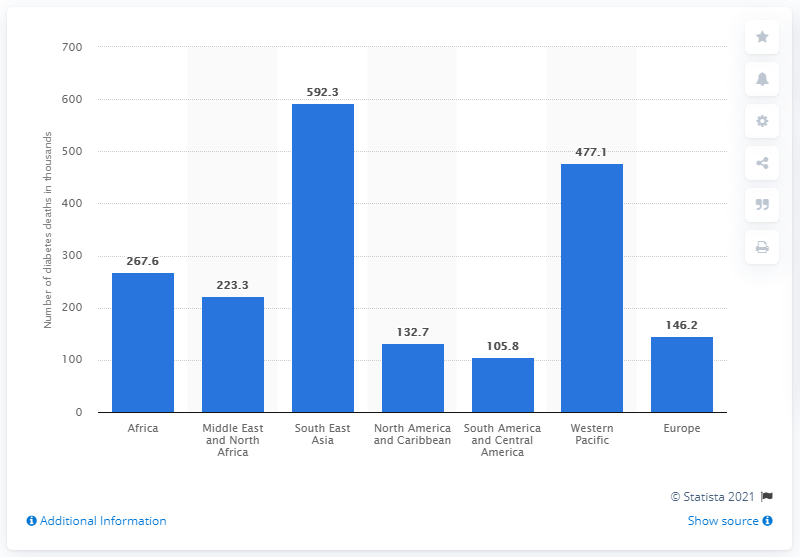Point out several critical features in this image. According to data from 2019, South America and Central America had the lowest number of diabetes-related deaths among all regions in the world. 